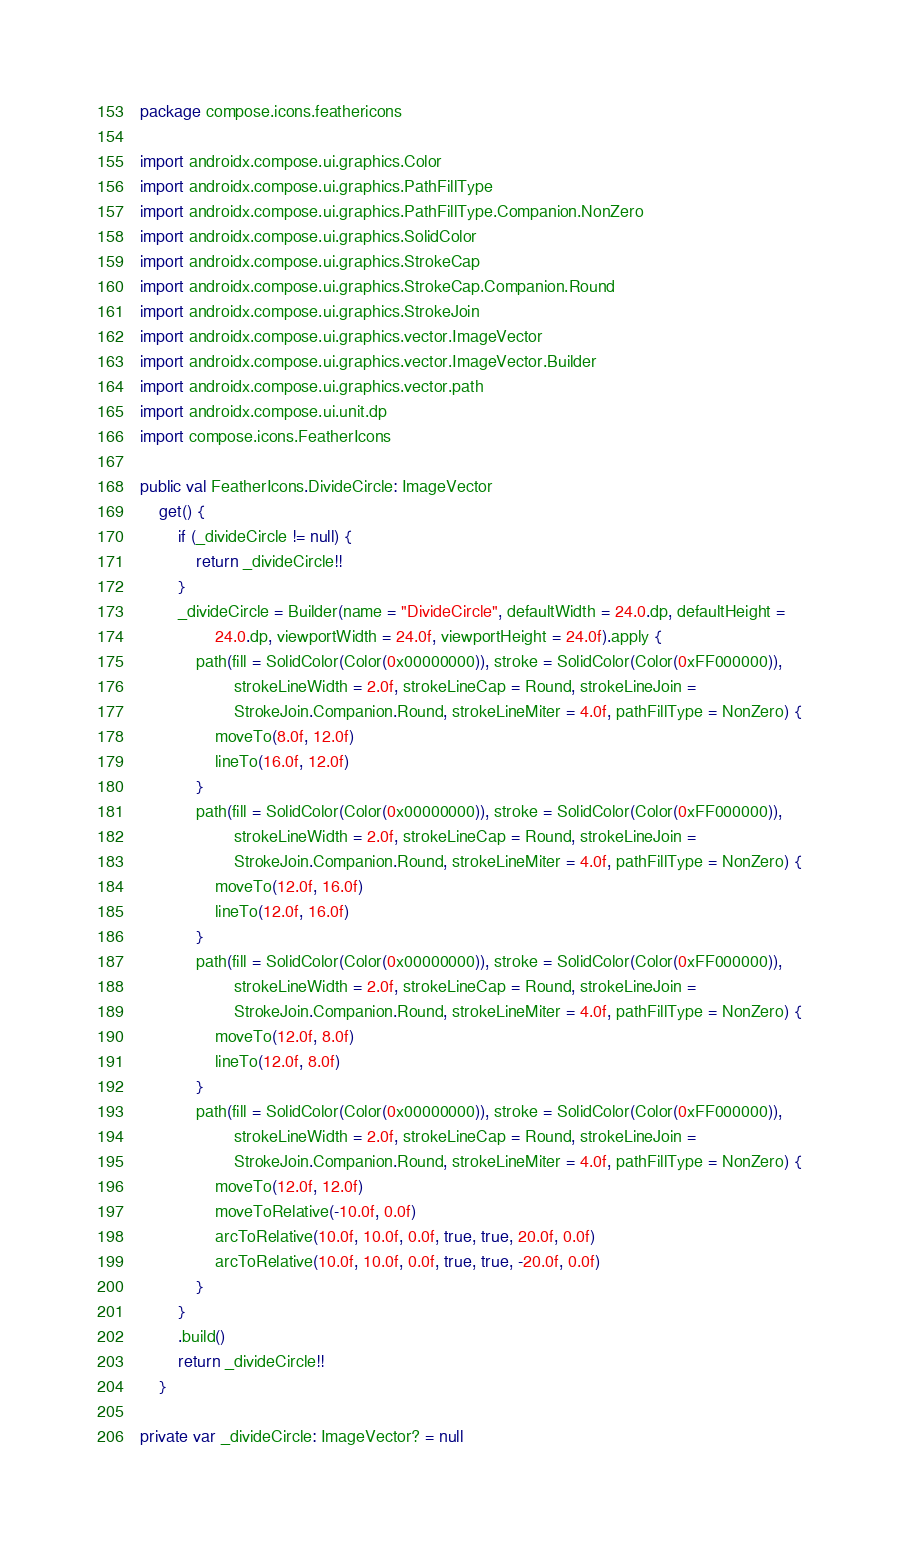Convert code to text. <code><loc_0><loc_0><loc_500><loc_500><_Kotlin_>package compose.icons.feathericons

import androidx.compose.ui.graphics.Color
import androidx.compose.ui.graphics.PathFillType
import androidx.compose.ui.graphics.PathFillType.Companion.NonZero
import androidx.compose.ui.graphics.SolidColor
import androidx.compose.ui.graphics.StrokeCap
import androidx.compose.ui.graphics.StrokeCap.Companion.Round
import androidx.compose.ui.graphics.StrokeJoin
import androidx.compose.ui.graphics.vector.ImageVector
import androidx.compose.ui.graphics.vector.ImageVector.Builder
import androidx.compose.ui.graphics.vector.path
import androidx.compose.ui.unit.dp
import compose.icons.FeatherIcons

public val FeatherIcons.DivideCircle: ImageVector
    get() {
        if (_divideCircle != null) {
            return _divideCircle!!
        }
        _divideCircle = Builder(name = "DivideCircle", defaultWidth = 24.0.dp, defaultHeight =
                24.0.dp, viewportWidth = 24.0f, viewportHeight = 24.0f).apply {
            path(fill = SolidColor(Color(0x00000000)), stroke = SolidColor(Color(0xFF000000)),
                    strokeLineWidth = 2.0f, strokeLineCap = Round, strokeLineJoin =
                    StrokeJoin.Companion.Round, strokeLineMiter = 4.0f, pathFillType = NonZero) {
                moveTo(8.0f, 12.0f)
                lineTo(16.0f, 12.0f)
            }
            path(fill = SolidColor(Color(0x00000000)), stroke = SolidColor(Color(0xFF000000)),
                    strokeLineWidth = 2.0f, strokeLineCap = Round, strokeLineJoin =
                    StrokeJoin.Companion.Round, strokeLineMiter = 4.0f, pathFillType = NonZero) {
                moveTo(12.0f, 16.0f)
                lineTo(12.0f, 16.0f)
            }
            path(fill = SolidColor(Color(0x00000000)), stroke = SolidColor(Color(0xFF000000)),
                    strokeLineWidth = 2.0f, strokeLineCap = Round, strokeLineJoin =
                    StrokeJoin.Companion.Round, strokeLineMiter = 4.0f, pathFillType = NonZero) {
                moveTo(12.0f, 8.0f)
                lineTo(12.0f, 8.0f)
            }
            path(fill = SolidColor(Color(0x00000000)), stroke = SolidColor(Color(0xFF000000)),
                    strokeLineWidth = 2.0f, strokeLineCap = Round, strokeLineJoin =
                    StrokeJoin.Companion.Round, strokeLineMiter = 4.0f, pathFillType = NonZero) {
                moveTo(12.0f, 12.0f)
                moveToRelative(-10.0f, 0.0f)
                arcToRelative(10.0f, 10.0f, 0.0f, true, true, 20.0f, 0.0f)
                arcToRelative(10.0f, 10.0f, 0.0f, true, true, -20.0f, 0.0f)
            }
        }
        .build()
        return _divideCircle!!
    }

private var _divideCircle: ImageVector? = null
</code> 